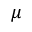<formula> <loc_0><loc_0><loc_500><loc_500>\mu</formula> 